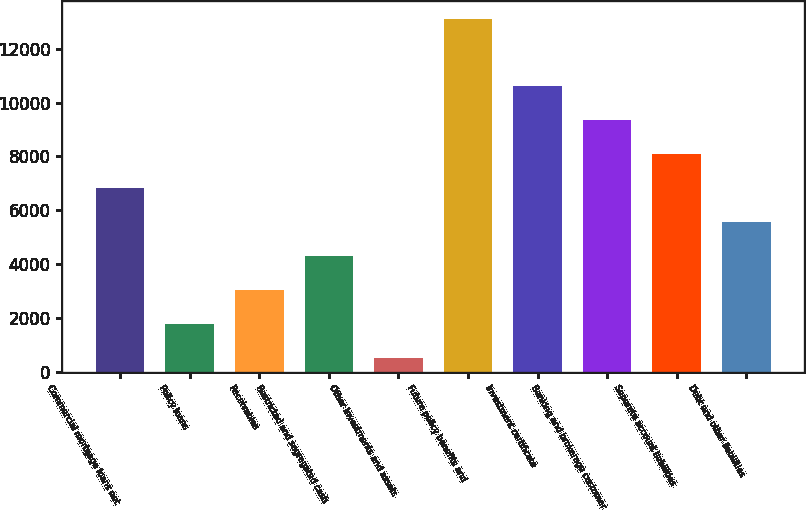Convert chart. <chart><loc_0><loc_0><loc_500><loc_500><bar_chart><fcel>Commercial mortgage loans net<fcel>Policy loans<fcel>Receivables<fcel>Restricted and segregated cash<fcel>Other investments and assets<fcel>Future policy benefits and<fcel>Investment certificate<fcel>Banking and brokerage customer<fcel>Separate account liabilities<fcel>Debt and other liabilities<nl><fcel>6818.5<fcel>1780.5<fcel>3040<fcel>4299.5<fcel>521<fcel>13116<fcel>10597<fcel>9337.5<fcel>8078<fcel>5559<nl></chart> 